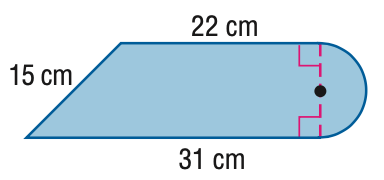Answer the mathemtical geometry problem and directly provide the correct option letter.
Question: Find the area of the figure. Round to the nearest tenth if necessary.
Choices: A: 374.5 B: 431.1 C: 692.5 D: 749.1 A 